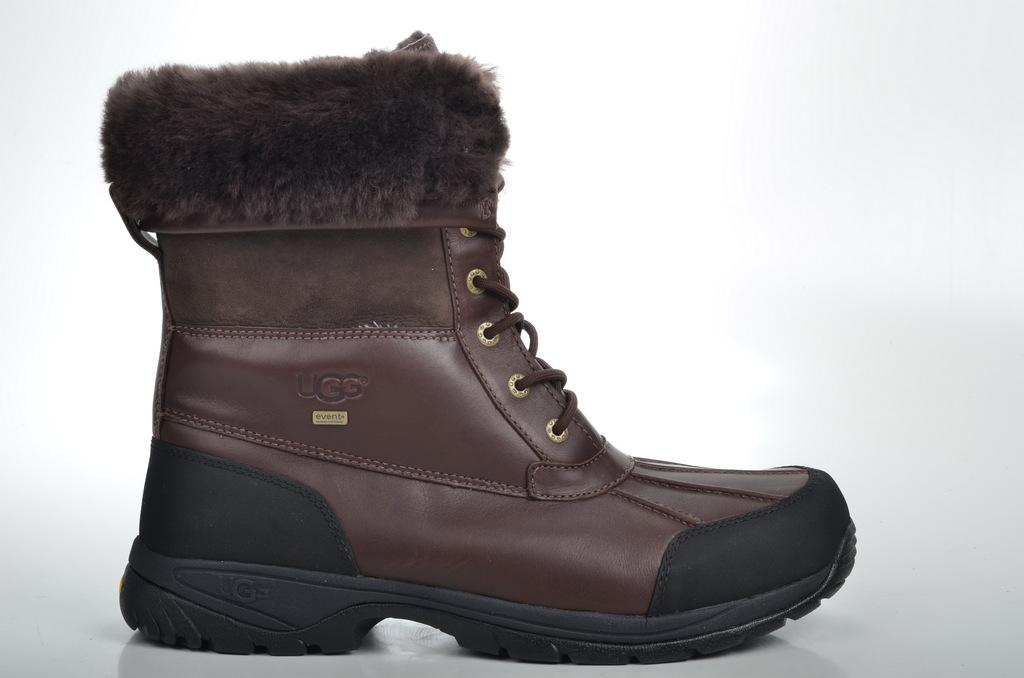What object is the main subject of the image? There is a boot in the image. What colors can be seen on the boot? The boot has brown and black colors. Are there any words or symbols on the boot? Yes, there is text on the boot. What other object is visible in the image? There is a brown color laser in the image. What color is the background of the image? The background of the image is white. What religious symbol can be seen on the boot in the image? There is no religious symbol present on the boot in the image. Is there a jail visible in the background of the image? There is no jail present in the image; the background is white. 